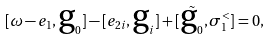Convert formula to latex. <formula><loc_0><loc_0><loc_500><loc_500>[ \omega - e _ { 1 } , \text  g_{0} ] - [ e _ { 2 i } , \text  g_{i} ] + [ \tilde { \text  g_{0} } , \sigma _ { 1 } ^ { < } ] = 0 ,</formula> 